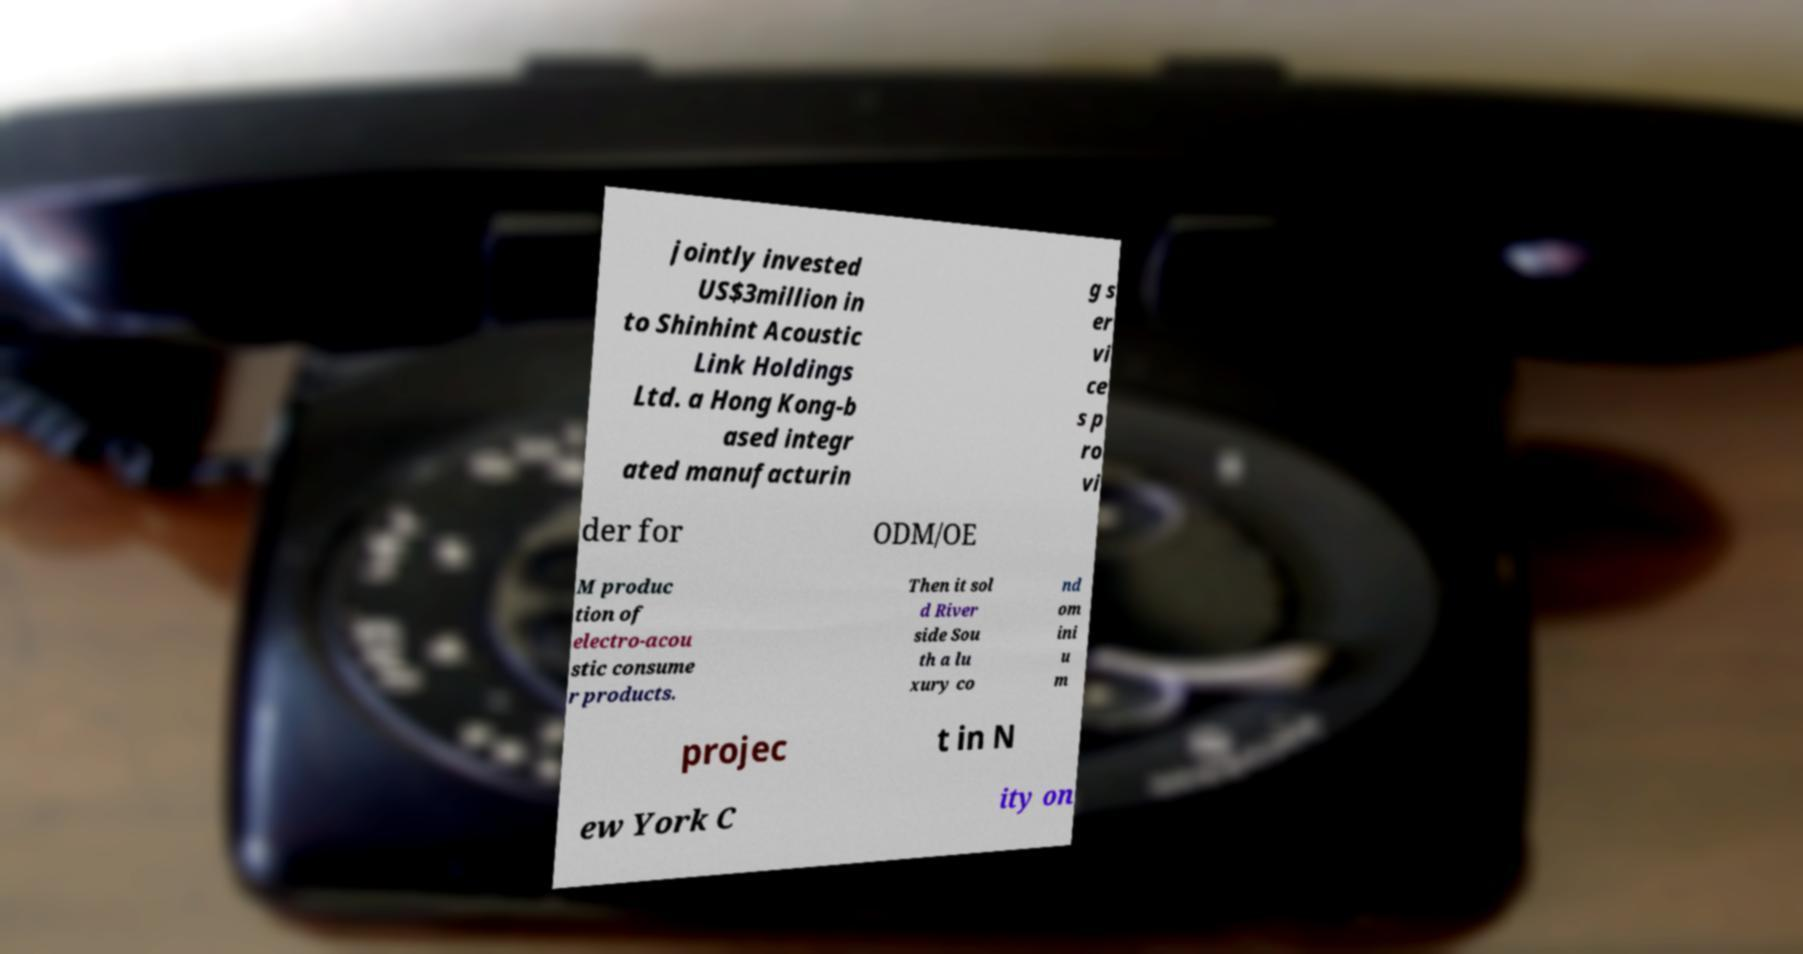Could you assist in decoding the text presented in this image and type it out clearly? jointly invested US$3million in to Shinhint Acoustic Link Holdings Ltd. a Hong Kong-b ased integr ated manufacturin g s er vi ce s p ro vi der for ODM/OE M produc tion of electro-acou stic consume r products. Then it sol d River side Sou th a lu xury co nd om ini u m projec t in N ew York C ity on 